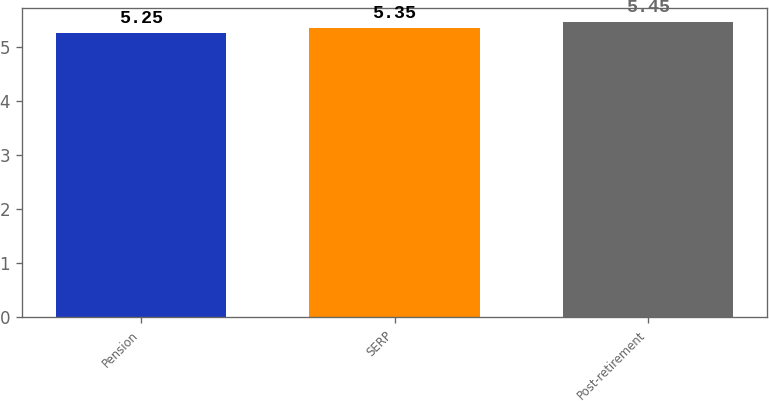Convert chart. <chart><loc_0><loc_0><loc_500><loc_500><bar_chart><fcel>Pension<fcel>SERP<fcel>Post-retirement<nl><fcel>5.25<fcel>5.35<fcel>5.45<nl></chart> 